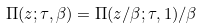Convert formula to latex. <formula><loc_0><loc_0><loc_500><loc_500>\Pi ( z ; \tau , \beta ) = \Pi ( z / \beta ; \tau , 1 ) / \beta</formula> 